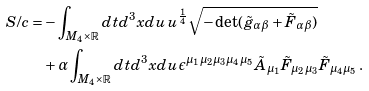Convert formula to latex. <formula><loc_0><loc_0><loc_500><loc_500>S / c = & - \int _ { M _ { 4 } \times \mathbb { R } } d t d ^ { 3 } x d u \, u ^ { \frac { 1 } { 4 } } \sqrt { - \det ( \tilde { g } _ { \alpha \beta } + { \tilde { F } } _ { \alpha \beta } ) } \\ & + \alpha \int _ { M _ { 4 } \times \mathbb { R } } d t d ^ { 3 } x d u \, \epsilon ^ { \mu _ { 1 } \mu _ { 2 } \mu _ { 3 } \mu _ { 4 } \mu _ { 5 } } \tilde { A } _ { \mu _ { 1 } } \tilde { F } _ { \mu _ { 2 } \mu _ { 3 } } \tilde { F } _ { \mu _ { 4 } \mu _ { 5 } } \, .</formula> 